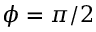<formula> <loc_0><loc_0><loc_500><loc_500>\phi = \pi / 2</formula> 